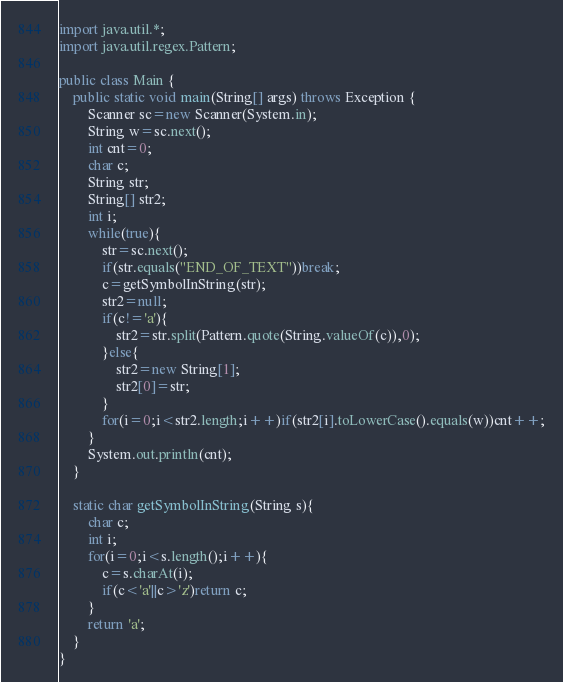<code> <loc_0><loc_0><loc_500><loc_500><_Java_>import java.util.*;
import java.util.regex.Pattern;

public class Main {
    public static void main(String[] args) throws Exception {
        Scanner sc=new Scanner(System.in);
        String w=sc.next();
        int cnt=0;
        char c;
        String str;
        String[] str2;
        int i;
        while(true){
            str=sc.next();
            if(str.equals("END_OF_TEXT"))break;
            c=getSymbolInString(str);
            str2=null;
            if(c!='a'){
                str2=str.split(Pattern.quote(String.valueOf(c)),0);
            }else{
                str2=new String[1];
                str2[0]=str;
            }
            for(i=0;i<str2.length;i++)if(str2[i].toLowerCase().equals(w))cnt++;
        }
        System.out.println(cnt);
    }
    
    static char getSymbolInString(String s){
        char c;
        int i;
        for(i=0;i<s.length();i++){
            c=s.charAt(i);
            if(c<'a'||c>'z')return c;
        }
        return 'a';
    }
}
</code> 